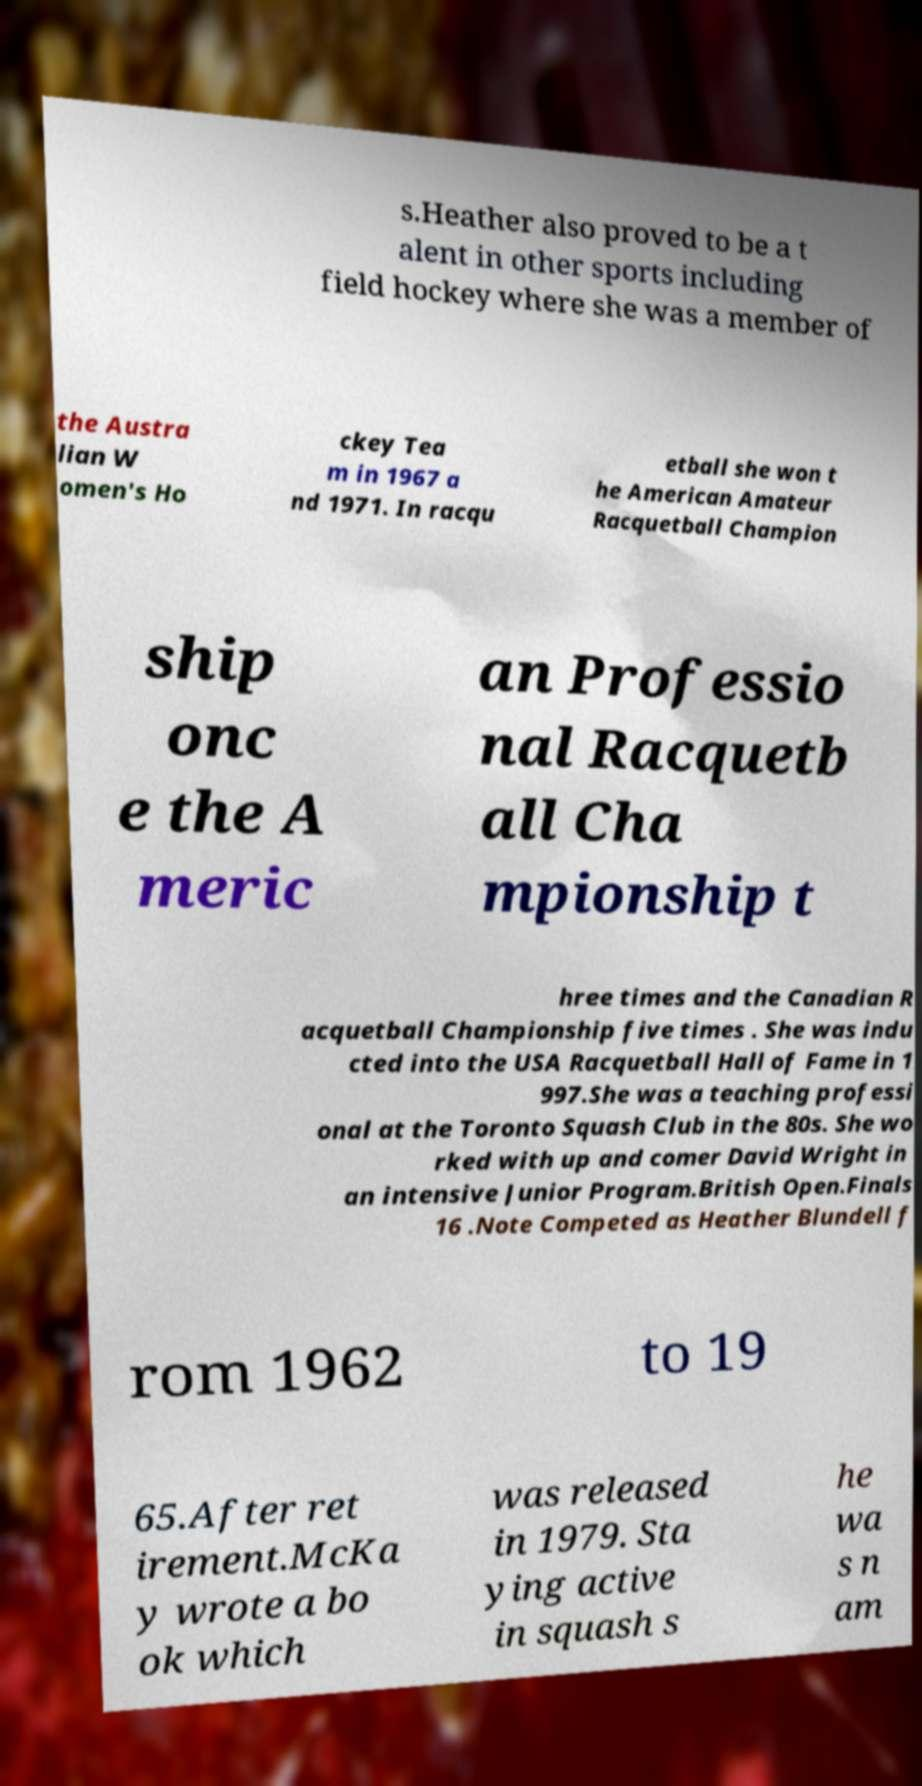Can you read and provide the text displayed in the image?This photo seems to have some interesting text. Can you extract and type it out for me? s.Heather also proved to be a t alent in other sports including field hockey where she was a member of the Austra lian W omen's Ho ckey Tea m in 1967 a nd 1971. In racqu etball she won t he American Amateur Racquetball Champion ship onc e the A meric an Professio nal Racquetb all Cha mpionship t hree times and the Canadian R acquetball Championship five times . She was indu cted into the USA Racquetball Hall of Fame in 1 997.She was a teaching professi onal at the Toronto Squash Club in the 80s. She wo rked with up and comer David Wright in an intensive Junior Program.British Open.Finals 16 .Note Competed as Heather Blundell f rom 1962 to 19 65.After ret irement.McKa y wrote a bo ok which was released in 1979. Sta ying active in squash s he wa s n am 